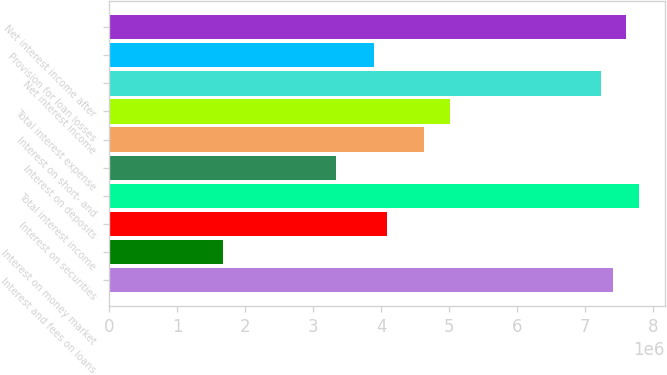Convert chart. <chart><loc_0><loc_0><loc_500><loc_500><bar_chart><fcel>Interest and fees on loans<fcel>Interest on money market<fcel>Interest on securities<fcel>Total interest income<fcel>Interest on deposits<fcel>Interest on short- and<fcel>Total interest expense<fcel>Net interest income<fcel>Provision for loan losses<fcel>Net interest income after<nl><fcel>7.412e+06<fcel>1.6677e+06<fcel>4.0766e+06<fcel>7.7826e+06<fcel>3.3354e+06<fcel>4.6325e+06<fcel>5.0031e+06<fcel>7.2267e+06<fcel>3.8913e+06<fcel>7.5973e+06<nl></chart> 